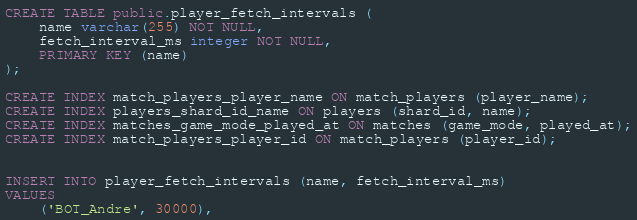Convert code to text. <code><loc_0><loc_0><loc_500><loc_500><_SQL_>CREATE TABLE public.player_fetch_intervals (
    name varchar(255) NOT NULL,
    fetch_interval_ms integer NOT NULL,
    PRIMARY KEY (name)
);

CREATE INDEX match_players_player_name ON match_players (player_name);
CREATE INDEX players_shard_id_name ON players (shard_id, name);
CREATE INDEX matches_game_mode_played_at ON matches (game_mode, played_at);
CREATE INDEX match_players_player_id ON match_players (player_id);


INSERT INTO player_fetch_intervals (name, fetch_interval_ms)
VALUES
    ('BOT_Andre', 30000),</code> 